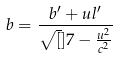Convert formula to latex. <formula><loc_0><loc_0><loc_500><loc_500>b = \frac { b ^ { \prime } + u l ^ { \prime } } { \sqrt { [ } ] { 7 - \frac { u ^ { 2 } } { c ^ { 2 } } } }</formula> 